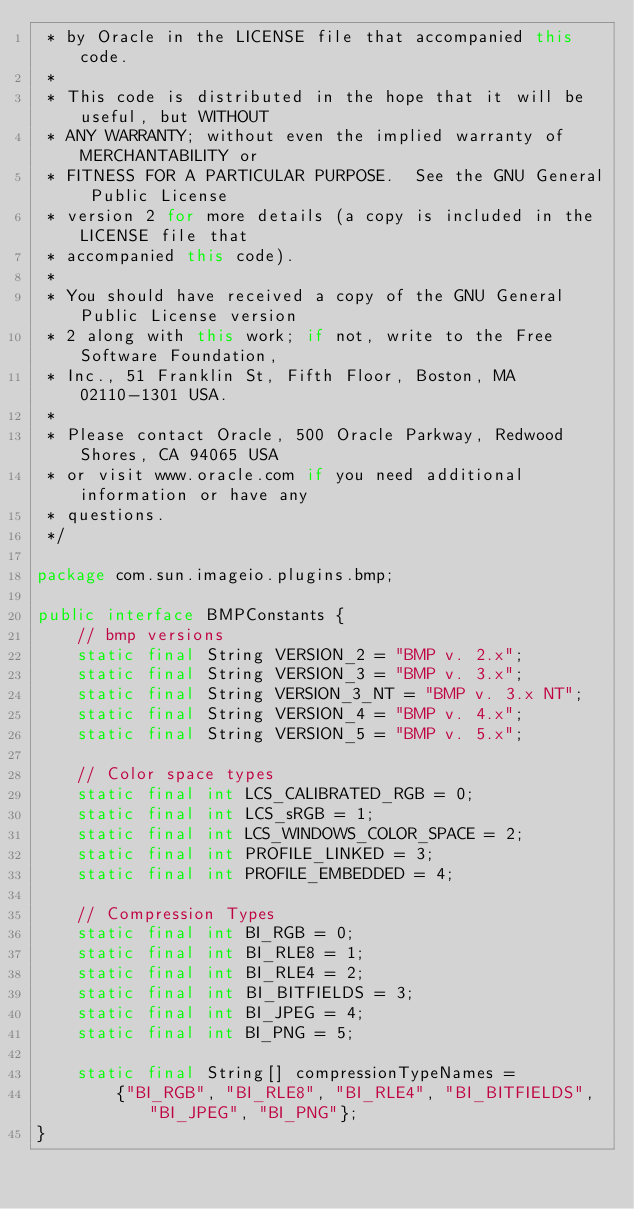Convert code to text. <code><loc_0><loc_0><loc_500><loc_500><_Java_> * by Oracle in the LICENSE file that accompanied this code.
 *
 * This code is distributed in the hope that it will be useful, but WITHOUT
 * ANY WARRANTY; without even the implied warranty of MERCHANTABILITY or
 * FITNESS FOR A PARTICULAR PURPOSE.  See the GNU General Public License
 * version 2 for more details (a copy is included in the LICENSE file that
 * accompanied this code).
 *
 * You should have received a copy of the GNU General Public License version
 * 2 along with this work; if not, write to the Free Software Foundation,
 * Inc., 51 Franklin St, Fifth Floor, Boston, MA 02110-1301 USA.
 *
 * Please contact Oracle, 500 Oracle Parkway, Redwood Shores, CA 94065 USA
 * or visit www.oracle.com if you need additional information or have any
 * questions.
 */

package com.sun.imageio.plugins.bmp;

public interface BMPConstants {
    // bmp versions
    static final String VERSION_2 = "BMP v. 2.x";
    static final String VERSION_3 = "BMP v. 3.x";
    static final String VERSION_3_NT = "BMP v. 3.x NT";
    static final String VERSION_4 = "BMP v. 4.x";
    static final String VERSION_5 = "BMP v. 5.x";

    // Color space types
    static final int LCS_CALIBRATED_RGB = 0;
    static final int LCS_sRGB = 1;
    static final int LCS_WINDOWS_COLOR_SPACE = 2;
    static final int PROFILE_LINKED = 3;
    static final int PROFILE_EMBEDDED = 4;

    // Compression Types
    static final int BI_RGB = 0;
    static final int BI_RLE8 = 1;
    static final int BI_RLE4 = 2;
    static final int BI_BITFIELDS = 3;
    static final int BI_JPEG = 4;
    static final int BI_PNG = 5;

    static final String[] compressionTypeNames =
        {"BI_RGB", "BI_RLE8", "BI_RLE4", "BI_BITFIELDS", "BI_JPEG", "BI_PNG"};
}
</code> 